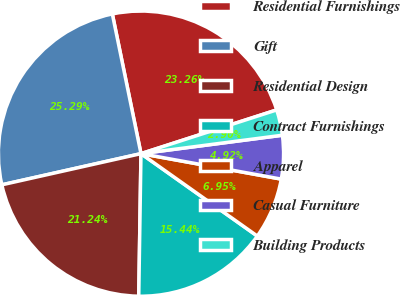<chart> <loc_0><loc_0><loc_500><loc_500><pie_chart><fcel>Residential Furnishings<fcel>Gift<fcel>Residential Design<fcel>Contract Furnishings<fcel>Apparel<fcel>Casual Furniture<fcel>Building Products<nl><fcel>23.26%<fcel>25.29%<fcel>21.24%<fcel>15.44%<fcel>6.95%<fcel>4.92%<fcel>2.9%<nl></chart> 